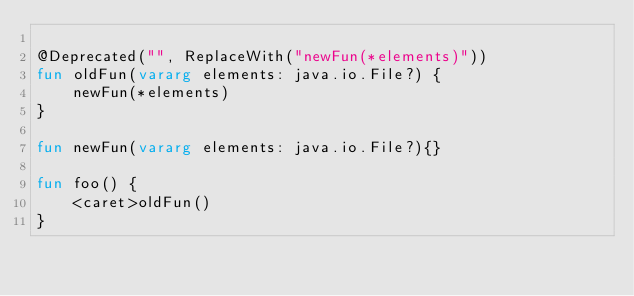<code> <loc_0><loc_0><loc_500><loc_500><_Kotlin_>
@Deprecated("", ReplaceWith("newFun(*elements)"))
fun oldFun(vararg elements: java.io.File?) {
    newFun(*elements)
}

fun newFun(vararg elements: java.io.File?){}

fun foo() {
    <caret>oldFun()
}
</code> 